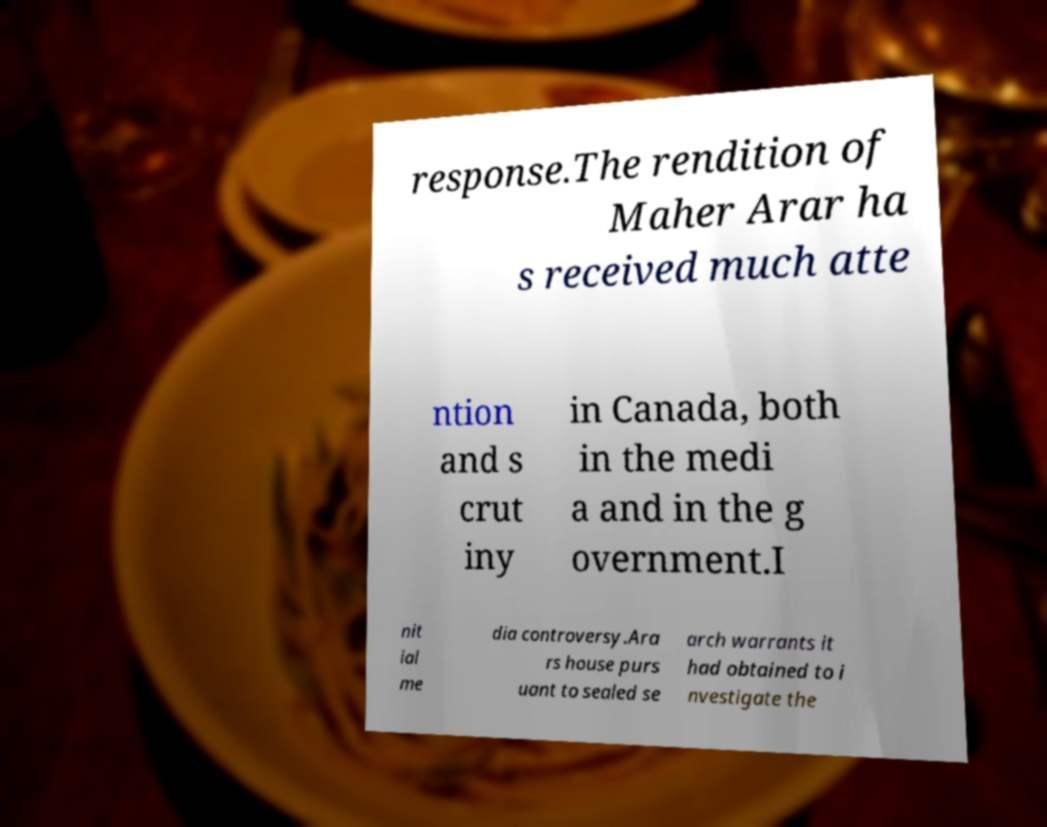Please read and relay the text visible in this image. What does it say? response.The rendition of Maher Arar ha s received much atte ntion and s crut iny in Canada, both in the medi a and in the g overnment.I nit ial me dia controversy.Ara rs house purs uant to sealed se arch warrants it had obtained to i nvestigate the 